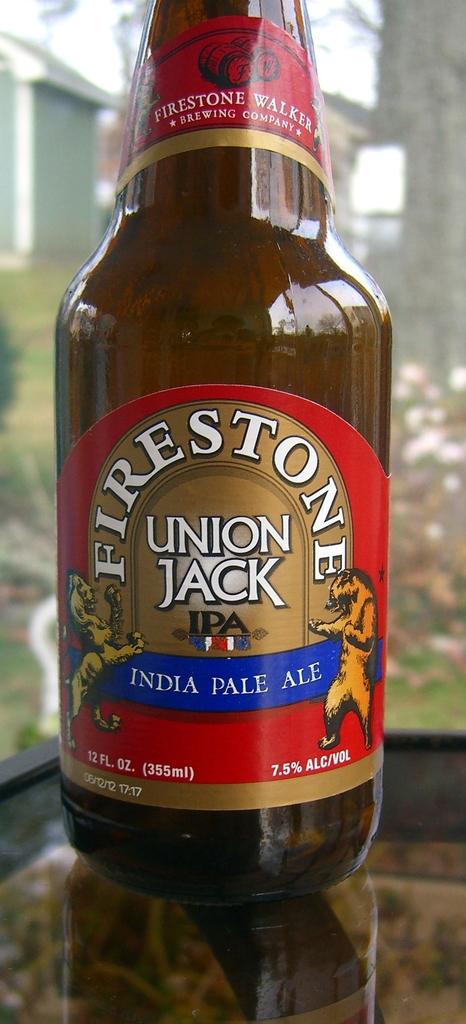How many ounces in this pale ale?
Provide a short and direct response. 12. What kind of ale is this?
Your answer should be very brief. India pale ale. 